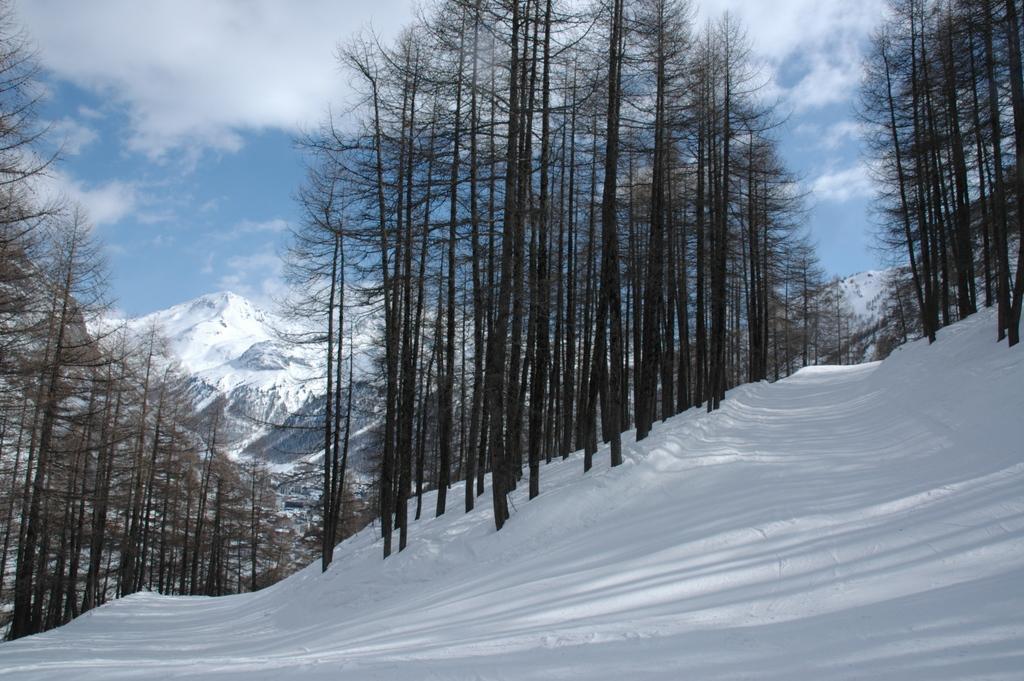In one or two sentences, can you explain what this image depicts? In this image I can see the snow and many trees. In the background I can see the mountains, clouds and the sky. I can see the mountains are covered with the snow. 